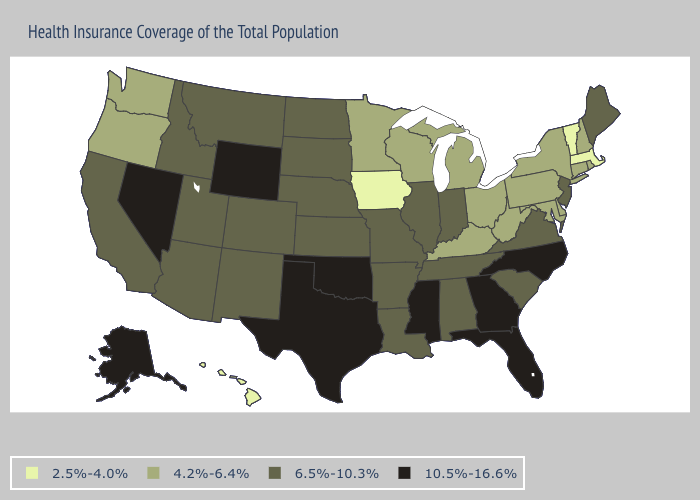Which states hav the highest value in the South?
Keep it brief. Florida, Georgia, Mississippi, North Carolina, Oklahoma, Texas. Does South Carolina have a lower value than Nevada?
Be succinct. Yes. What is the value of Rhode Island?
Be succinct. 4.2%-6.4%. Does Delaware have the same value as New Hampshire?
Keep it brief. Yes. What is the value of Wisconsin?
Answer briefly. 4.2%-6.4%. What is the lowest value in the MidWest?
Quick response, please. 2.5%-4.0%. What is the value of New Jersey?
Write a very short answer. 6.5%-10.3%. Does the map have missing data?
Concise answer only. No. Name the states that have a value in the range 6.5%-10.3%?
Be succinct. Alabama, Arizona, Arkansas, California, Colorado, Idaho, Illinois, Indiana, Kansas, Louisiana, Maine, Missouri, Montana, Nebraska, New Jersey, New Mexico, North Dakota, South Carolina, South Dakota, Tennessee, Utah, Virginia. Does Kentucky have the lowest value in the South?
Write a very short answer. Yes. Name the states that have a value in the range 10.5%-16.6%?
Keep it brief. Alaska, Florida, Georgia, Mississippi, Nevada, North Carolina, Oklahoma, Texas, Wyoming. What is the highest value in the USA?
Be succinct. 10.5%-16.6%. Among the states that border Kentucky , which have the highest value?
Be succinct. Illinois, Indiana, Missouri, Tennessee, Virginia. What is the lowest value in the Northeast?
Answer briefly. 2.5%-4.0%. 